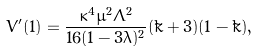Convert formula to latex. <formula><loc_0><loc_0><loc_500><loc_500>V ^ { \prime } ( 1 ) = \frac { \kappa ^ { 4 } \mu ^ { 2 } \Lambda ^ { 2 } } { 1 6 ( 1 - 3 \lambda ) ^ { 2 } } ( \tilde { k } + 3 ) ( 1 - \tilde { k } ) ,</formula> 